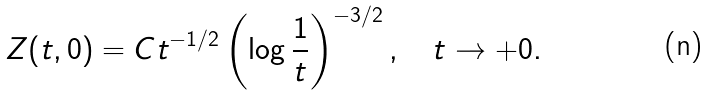<formula> <loc_0><loc_0><loc_500><loc_500>Z ( t , 0 ) = C t ^ { - 1 / 2 } \left ( \log \frac { 1 } t \right ) ^ { - 3 / 2 } , \quad t \to + 0 .</formula> 